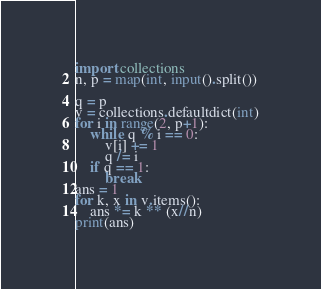Convert code to text. <code><loc_0><loc_0><loc_500><loc_500><_Python_>import collections
n, p = map(int, input().split())

q = p
v = collections.defaultdict(int)
for i in range(2, p+1):
    while q % i == 0:
        v[i] += 1
        q /= i
    if q == 1:
        break
ans = 1
for k, x in v.items():
    ans *= k ** (x//n)
print(ans)
</code> 